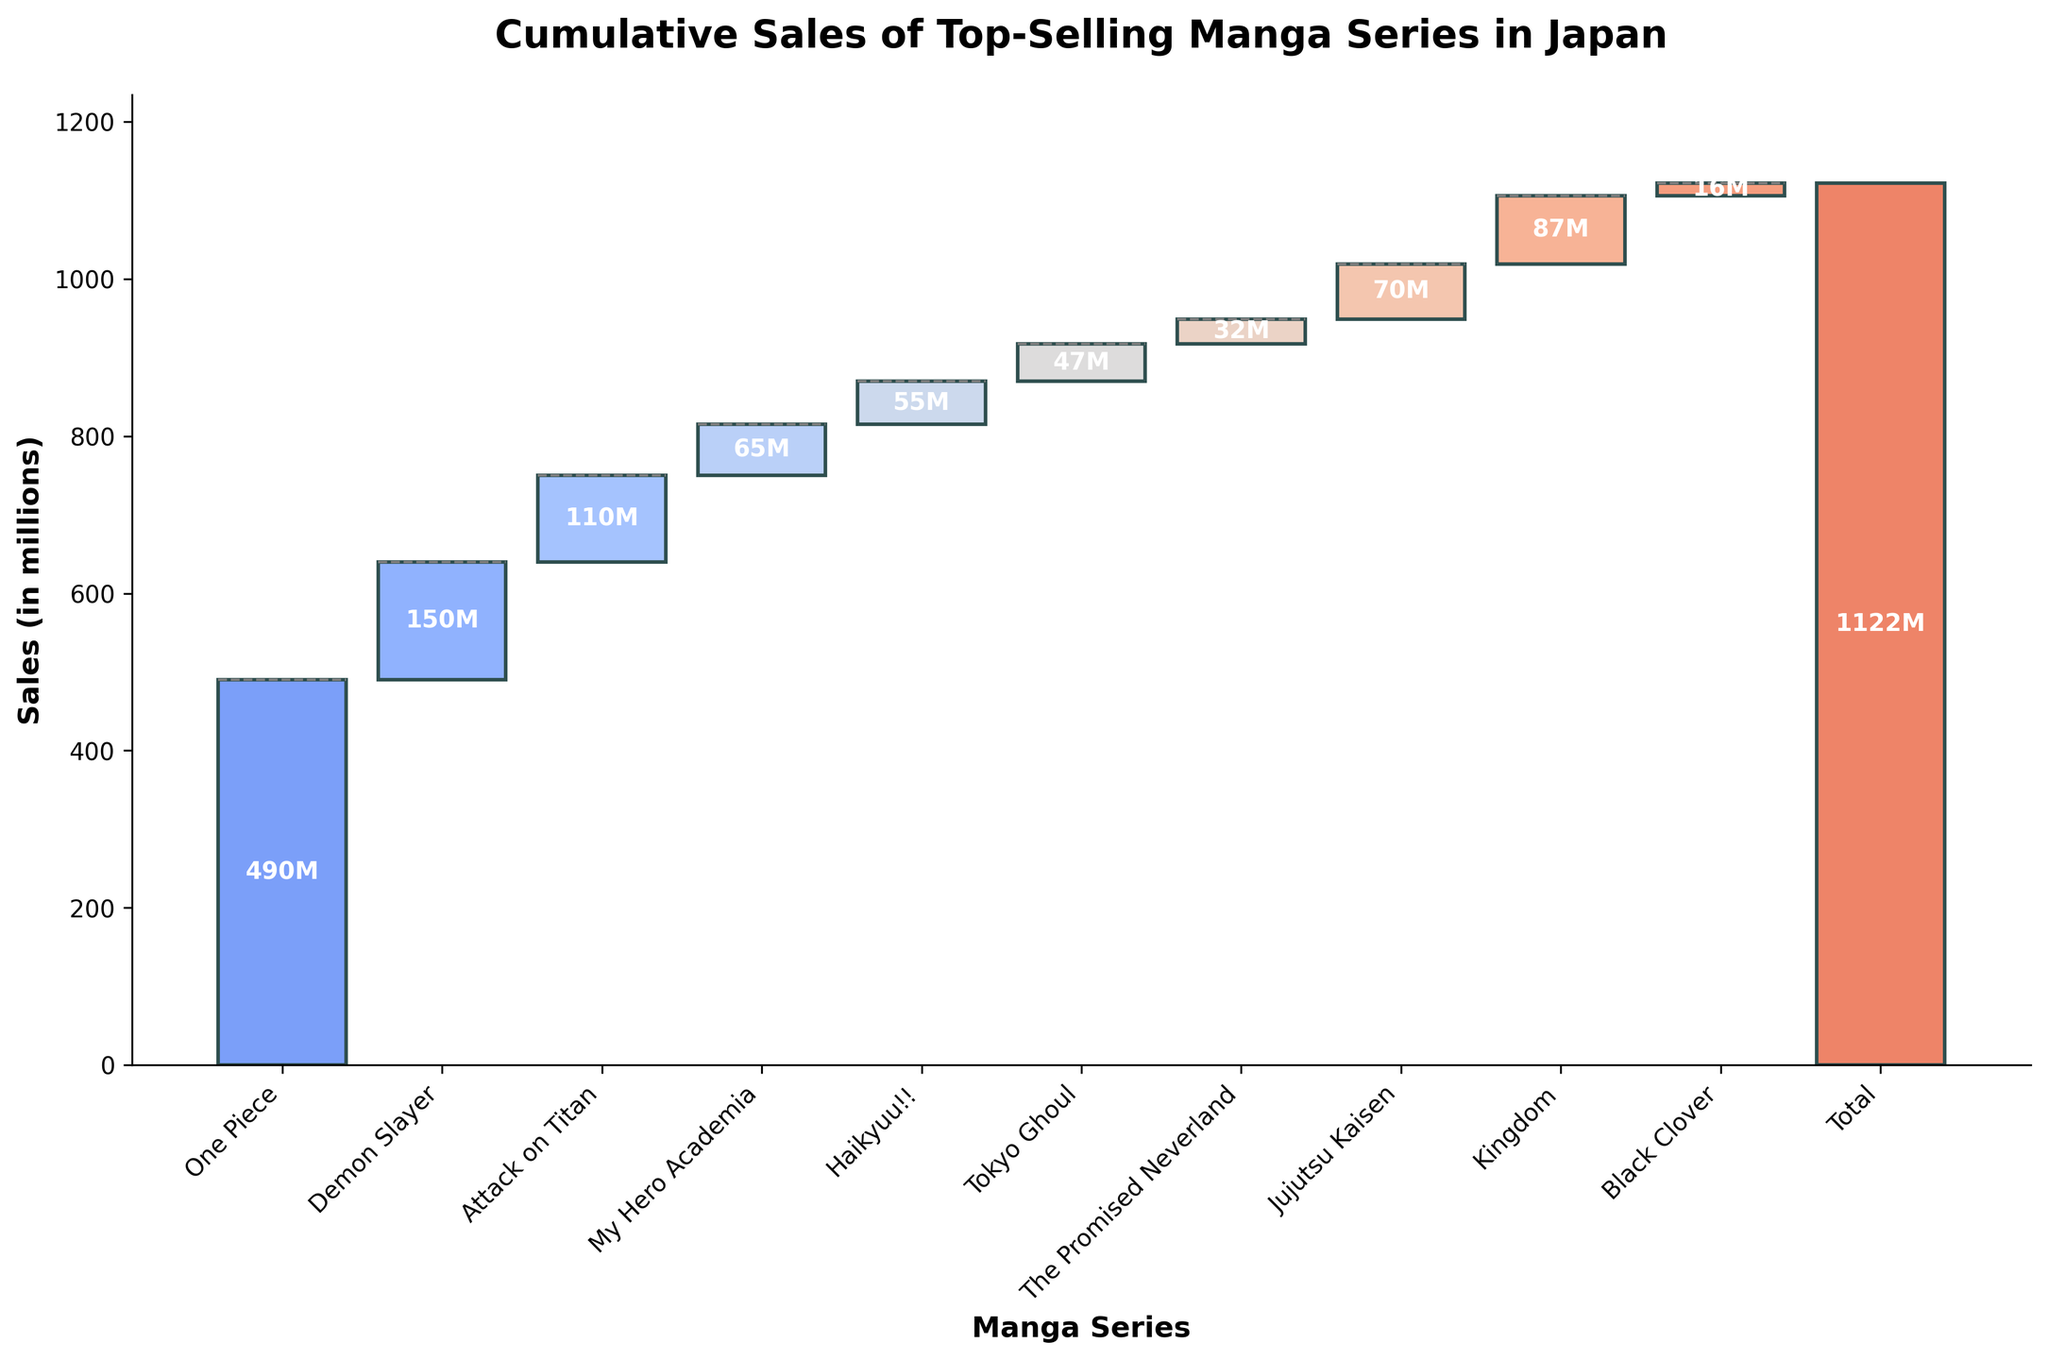What is the title of the chart? The title of the chart is prominently displayed at the top.
Answer: Cumulative Sales of Top-Selling Manga Series in Japan Which manga series has the highest individual sales figure? Identify the tallest bar in the chart, which represents the series with the highest sales.
Answer: One Piece How many manga series are included in the chart? Count the number of bars representing individual manga series in the waterfall chart.
Answer: 11 Which manga series has the lowest sales figure? Locate the shortest bar in the chart, which represents the series with the smallest sales figure.
Answer: Black Clover What is the cumulative sales figure for 'Demon Slayer' and 'Attack on Titan'? Add the sales figures of 'Demon Slayer' (150 million) and 'Attack on Titan' (110 million).
Answer: 260 million How much more did 'One Piece' sell compared to 'Demon Slayer'? Subtract the sales figure of 'Demon Slayer' (150 million) from 'One Piece' (490 million).
Answer: 340 million What is the total cumulative sales figure for the top three manga series? Sum the sales figures of 'One Piece', 'Demon Slayer', and 'Attack on Titan' (490 + 150 + 110 million).
Answer: 750 million Which manga series had sales figures contributing to reaching a cumulative sales milestone of over 200 million? Identify the series whose combined sales with preceding series' sales reached over 200 million: 'One Piece' (490 million) alone achieves this.
Answer: One Piece How does the cumulative sales figure of 'My Hero Academia' compare to 'Haikyuu!!'? Compare the sum of sales figures up to 'My Hero Academia' (490 + 150 + 110 + 65 million) with 'Haikyuu!!' (490 + 150 + 110 + 65 + 55 million).
Answer: Haikyuu!! has a higher cumulative value What sales figure would be needed by 'Black Clover' to contribute equally to cumulative sales as 'The Promised Neverland'? Equalize the difference between the individual sales of 'Black Clover' (16 million) and 'The Promised Neverland' (32 million).
Answer: 16 million more 